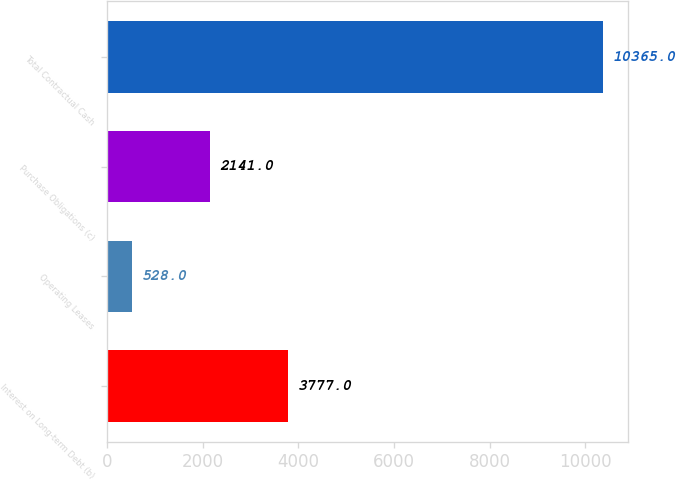Convert chart. <chart><loc_0><loc_0><loc_500><loc_500><bar_chart><fcel>Interest on Long-term Debt (b)<fcel>Operating Leases<fcel>Purchase Obligations (c)<fcel>Total Contractual Cash<nl><fcel>3777<fcel>528<fcel>2141<fcel>10365<nl></chart> 